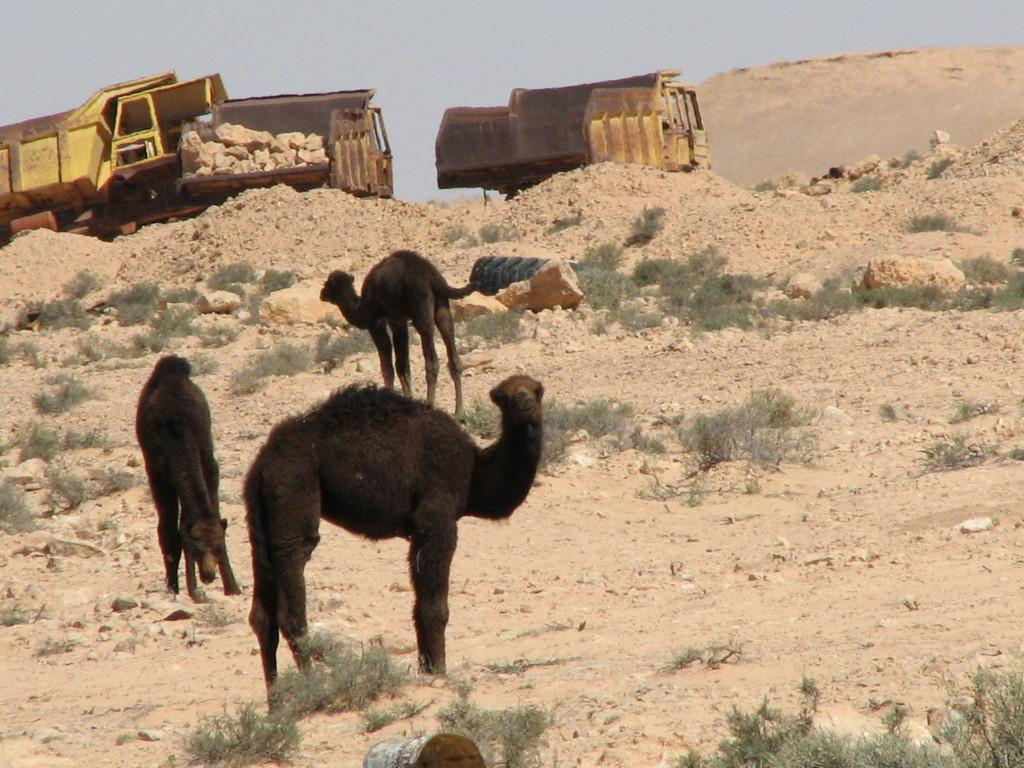What types of living organisms can be seen in the image? There are animals in the image. What can be seen beneath the animals and plants? The ground is visible in the image. What type of vegetation is present in the image? There are plants in the image. What material is present in the image that is not vegetation or animals? Stones and sand are visible in the image. What type of transportation is present in the image? Vehicles are present in the image. What is visible in the background of the image? The sky is visible in the background of the image. What is the owner of the low-flying aircraft doing in the image? There is no aircraft or owner present in the image. 